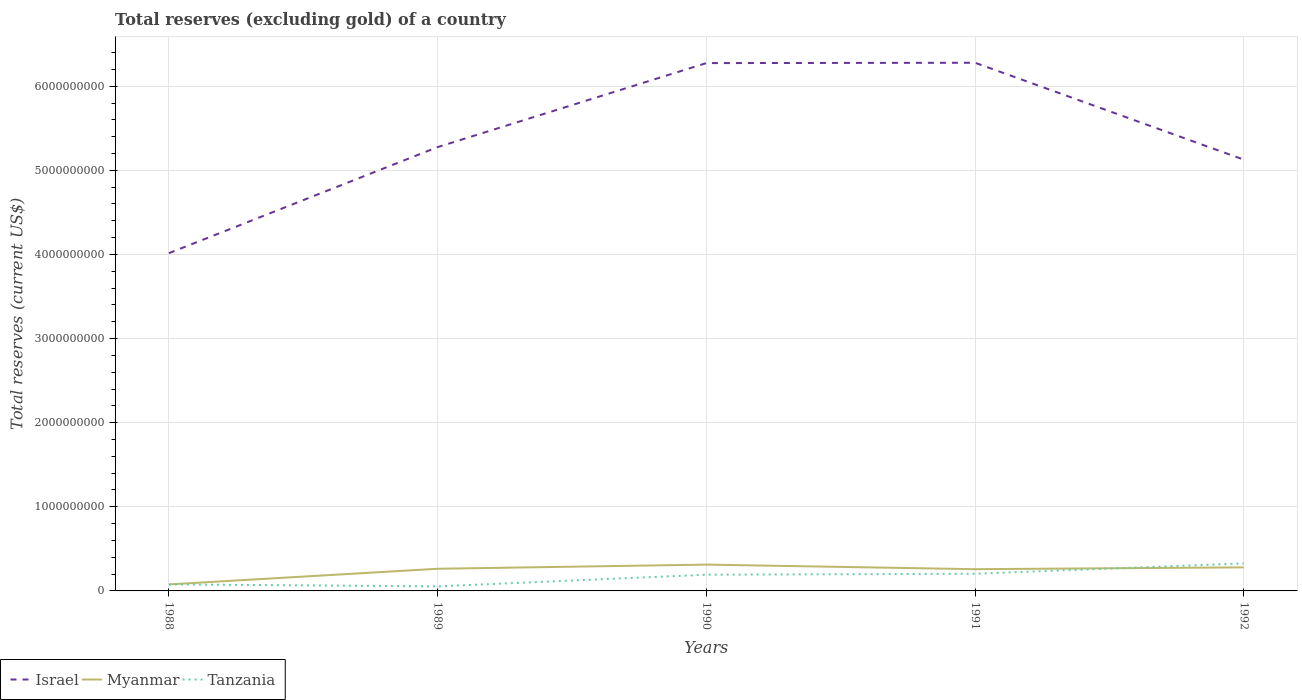Is the number of lines equal to the number of legend labels?
Your response must be concise. Yes. Across all years, what is the maximum total reserves (excluding gold) in Tanzania?
Provide a succinct answer. 5.42e+07. In which year was the total reserves (excluding gold) in Israel maximum?
Offer a terse response. 1988. What is the total total reserves (excluding gold) in Tanzania in the graph?
Make the answer very short. -1.26e+08. What is the difference between the highest and the second highest total reserves (excluding gold) in Israel?
Your response must be concise. 2.26e+09. How many lines are there?
Ensure brevity in your answer.  3. What is the difference between two consecutive major ticks on the Y-axis?
Your answer should be very brief. 1.00e+09. Does the graph contain any zero values?
Your response must be concise. No. Does the graph contain grids?
Make the answer very short. Yes. How are the legend labels stacked?
Give a very brief answer. Horizontal. What is the title of the graph?
Your response must be concise. Total reserves (excluding gold) of a country. Does "Norway" appear as one of the legend labels in the graph?
Your answer should be very brief. No. What is the label or title of the Y-axis?
Keep it short and to the point. Total reserves (current US$). What is the Total reserves (current US$) of Israel in 1988?
Your answer should be compact. 4.02e+09. What is the Total reserves (current US$) in Myanmar in 1988?
Offer a terse response. 7.74e+07. What is the Total reserves (current US$) in Tanzania in 1988?
Give a very brief answer. 7.77e+07. What is the Total reserves (current US$) in Israel in 1989?
Provide a short and direct response. 5.28e+09. What is the Total reserves (current US$) in Myanmar in 1989?
Make the answer very short. 2.63e+08. What is the Total reserves (current US$) of Tanzania in 1989?
Give a very brief answer. 5.42e+07. What is the Total reserves (current US$) of Israel in 1990?
Provide a short and direct response. 6.28e+09. What is the Total reserves (current US$) in Myanmar in 1990?
Ensure brevity in your answer.  3.13e+08. What is the Total reserves (current US$) of Tanzania in 1990?
Your answer should be very brief. 1.93e+08. What is the Total reserves (current US$) in Israel in 1991?
Provide a succinct answer. 6.28e+09. What is the Total reserves (current US$) of Myanmar in 1991?
Your answer should be very brief. 2.58e+08. What is the Total reserves (current US$) of Tanzania in 1991?
Keep it short and to the point. 2.04e+08. What is the Total reserves (current US$) of Israel in 1992?
Keep it short and to the point. 5.13e+09. What is the Total reserves (current US$) of Myanmar in 1992?
Your answer should be compact. 2.80e+08. What is the Total reserves (current US$) in Tanzania in 1992?
Your answer should be compact. 3.27e+08. Across all years, what is the maximum Total reserves (current US$) of Israel?
Offer a terse response. 6.28e+09. Across all years, what is the maximum Total reserves (current US$) of Myanmar?
Ensure brevity in your answer.  3.13e+08. Across all years, what is the maximum Total reserves (current US$) in Tanzania?
Ensure brevity in your answer.  3.27e+08. Across all years, what is the minimum Total reserves (current US$) of Israel?
Ensure brevity in your answer.  4.02e+09. Across all years, what is the minimum Total reserves (current US$) of Myanmar?
Your response must be concise. 7.74e+07. Across all years, what is the minimum Total reserves (current US$) of Tanzania?
Provide a succinct answer. 5.42e+07. What is the total Total reserves (current US$) of Israel in the graph?
Offer a very short reply. 2.70e+1. What is the total Total reserves (current US$) of Myanmar in the graph?
Provide a short and direct response. 1.19e+09. What is the total Total reserves (current US$) of Tanzania in the graph?
Provide a succinct answer. 8.56e+08. What is the difference between the Total reserves (current US$) in Israel in 1988 and that in 1989?
Your answer should be very brief. -1.26e+09. What is the difference between the Total reserves (current US$) in Myanmar in 1988 and that in 1989?
Provide a succinct answer. -1.86e+08. What is the difference between the Total reserves (current US$) of Tanzania in 1988 and that in 1989?
Provide a short and direct response. 2.35e+07. What is the difference between the Total reserves (current US$) in Israel in 1988 and that in 1990?
Your answer should be very brief. -2.26e+09. What is the difference between the Total reserves (current US$) of Myanmar in 1988 and that in 1990?
Your answer should be compact. -2.35e+08. What is the difference between the Total reserves (current US$) in Tanzania in 1988 and that in 1990?
Your answer should be compact. -1.15e+08. What is the difference between the Total reserves (current US$) of Israel in 1988 and that in 1991?
Provide a short and direct response. -2.26e+09. What is the difference between the Total reserves (current US$) of Myanmar in 1988 and that in 1991?
Your answer should be compact. -1.81e+08. What is the difference between the Total reserves (current US$) in Tanzania in 1988 and that in 1991?
Keep it short and to the point. -1.26e+08. What is the difference between the Total reserves (current US$) in Israel in 1988 and that in 1992?
Provide a succinct answer. -1.11e+09. What is the difference between the Total reserves (current US$) in Myanmar in 1988 and that in 1992?
Give a very brief answer. -2.03e+08. What is the difference between the Total reserves (current US$) of Tanzania in 1988 and that in 1992?
Your response must be concise. -2.50e+08. What is the difference between the Total reserves (current US$) of Israel in 1989 and that in 1990?
Keep it short and to the point. -9.99e+08. What is the difference between the Total reserves (current US$) of Myanmar in 1989 and that in 1990?
Ensure brevity in your answer.  -4.94e+07. What is the difference between the Total reserves (current US$) of Tanzania in 1989 and that in 1990?
Ensure brevity in your answer.  -1.39e+08. What is the difference between the Total reserves (current US$) of Israel in 1989 and that in 1991?
Make the answer very short. -1.00e+09. What is the difference between the Total reserves (current US$) of Myanmar in 1989 and that in 1991?
Offer a terse response. 4.99e+06. What is the difference between the Total reserves (current US$) of Tanzania in 1989 and that in 1991?
Make the answer very short. -1.50e+08. What is the difference between the Total reserves (current US$) in Israel in 1989 and that in 1992?
Provide a succinct answer. 1.49e+08. What is the difference between the Total reserves (current US$) in Myanmar in 1989 and that in 1992?
Give a very brief answer. -1.67e+07. What is the difference between the Total reserves (current US$) in Tanzania in 1989 and that in 1992?
Your answer should be very brief. -2.73e+08. What is the difference between the Total reserves (current US$) of Israel in 1990 and that in 1991?
Offer a very short reply. -3.96e+06. What is the difference between the Total reserves (current US$) of Myanmar in 1990 and that in 1991?
Provide a succinct answer. 5.44e+07. What is the difference between the Total reserves (current US$) of Tanzania in 1990 and that in 1991?
Offer a terse response. -1.11e+07. What is the difference between the Total reserves (current US$) of Israel in 1990 and that in 1992?
Provide a succinct answer. 1.15e+09. What is the difference between the Total reserves (current US$) in Myanmar in 1990 and that in 1992?
Ensure brevity in your answer.  3.27e+07. What is the difference between the Total reserves (current US$) of Tanzania in 1990 and that in 1992?
Give a very brief answer. -1.35e+08. What is the difference between the Total reserves (current US$) in Israel in 1991 and that in 1992?
Give a very brief answer. 1.15e+09. What is the difference between the Total reserves (current US$) of Myanmar in 1991 and that in 1992?
Ensure brevity in your answer.  -2.17e+07. What is the difference between the Total reserves (current US$) of Tanzania in 1991 and that in 1992?
Give a very brief answer. -1.23e+08. What is the difference between the Total reserves (current US$) of Israel in 1988 and the Total reserves (current US$) of Myanmar in 1989?
Your response must be concise. 3.75e+09. What is the difference between the Total reserves (current US$) of Israel in 1988 and the Total reserves (current US$) of Tanzania in 1989?
Ensure brevity in your answer.  3.96e+09. What is the difference between the Total reserves (current US$) in Myanmar in 1988 and the Total reserves (current US$) in Tanzania in 1989?
Offer a very short reply. 2.32e+07. What is the difference between the Total reserves (current US$) of Israel in 1988 and the Total reserves (current US$) of Myanmar in 1990?
Offer a terse response. 3.70e+09. What is the difference between the Total reserves (current US$) in Israel in 1988 and the Total reserves (current US$) in Tanzania in 1990?
Your response must be concise. 3.82e+09. What is the difference between the Total reserves (current US$) of Myanmar in 1988 and the Total reserves (current US$) of Tanzania in 1990?
Offer a very short reply. -1.15e+08. What is the difference between the Total reserves (current US$) in Israel in 1988 and the Total reserves (current US$) in Myanmar in 1991?
Provide a short and direct response. 3.76e+09. What is the difference between the Total reserves (current US$) in Israel in 1988 and the Total reserves (current US$) in Tanzania in 1991?
Make the answer very short. 3.81e+09. What is the difference between the Total reserves (current US$) of Myanmar in 1988 and the Total reserves (current US$) of Tanzania in 1991?
Your response must be concise. -1.26e+08. What is the difference between the Total reserves (current US$) of Israel in 1988 and the Total reserves (current US$) of Myanmar in 1992?
Provide a succinct answer. 3.74e+09. What is the difference between the Total reserves (current US$) in Israel in 1988 and the Total reserves (current US$) in Tanzania in 1992?
Your answer should be compact. 3.69e+09. What is the difference between the Total reserves (current US$) of Myanmar in 1988 and the Total reserves (current US$) of Tanzania in 1992?
Your response must be concise. -2.50e+08. What is the difference between the Total reserves (current US$) of Israel in 1989 and the Total reserves (current US$) of Myanmar in 1990?
Offer a very short reply. 4.96e+09. What is the difference between the Total reserves (current US$) of Israel in 1989 and the Total reserves (current US$) of Tanzania in 1990?
Keep it short and to the point. 5.08e+09. What is the difference between the Total reserves (current US$) in Myanmar in 1989 and the Total reserves (current US$) in Tanzania in 1990?
Ensure brevity in your answer.  7.06e+07. What is the difference between the Total reserves (current US$) of Israel in 1989 and the Total reserves (current US$) of Myanmar in 1991?
Keep it short and to the point. 5.02e+09. What is the difference between the Total reserves (current US$) in Israel in 1989 and the Total reserves (current US$) in Tanzania in 1991?
Give a very brief answer. 5.07e+09. What is the difference between the Total reserves (current US$) in Myanmar in 1989 and the Total reserves (current US$) in Tanzania in 1991?
Your answer should be compact. 5.95e+07. What is the difference between the Total reserves (current US$) of Israel in 1989 and the Total reserves (current US$) of Myanmar in 1992?
Keep it short and to the point. 5.00e+09. What is the difference between the Total reserves (current US$) in Israel in 1989 and the Total reserves (current US$) in Tanzania in 1992?
Your answer should be compact. 4.95e+09. What is the difference between the Total reserves (current US$) in Myanmar in 1989 and the Total reserves (current US$) in Tanzania in 1992?
Give a very brief answer. -6.40e+07. What is the difference between the Total reserves (current US$) of Israel in 1990 and the Total reserves (current US$) of Myanmar in 1991?
Make the answer very short. 6.02e+09. What is the difference between the Total reserves (current US$) of Israel in 1990 and the Total reserves (current US$) of Tanzania in 1991?
Keep it short and to the point. 6.07e+09. What is the difference between the Total reserves (current US$) of Myanmar in 1990 and the Total reserves (current US$) of Tanzania in 1991?
Provide a succinct answer. 1.09e+08. What is the difference between the Total reserves (current US$) of Israel in 1990 and the Total reserves (current US$) of Myanmar in 1992?
Offer a very short reply. 6.00e+09. What is the difference between the Total reserves (current US$) of Israel in 1990 and the Total reserves (current US$) of Tanzania in 1992?
Provide a succinct answer. 5.95e+09. What is the difference between the Total reserves (current US$) of Myanmar in 1990 and the Total reserves (current US$) of Tanzania in 1992?
Give a very brief answer. -1.45e+07. What is the difference between the Total reserves (current US$) in Israel in 1991 and the Total reserves (current US$) in Myanmar in 1992?
Give a very brief answer. 6.00e+09. What is the difference between the Total reserves (current US$) in Israel in 1991 and the Total reserves (current US$) in Tanzania in 1992?
Your response must be concise. 5.95e+09. What is the difference between the Total reserves (current US$) of Myanmar in 1991 and the Total reserves (current US$) of Tanzania in 1992?
Provide a short and direct response. -6.90e+07. What is the average Total reserves (current US$) of Israel per year?
Your response must be concise. 5.39e+09. What is the average Total reserves (current US$) of Myanmar per year?
Offer a very short reply. 2.38e+08. What is the average Total reserves (current US$) in Tanzania per year?
Offer a terse response. 1.71e+08. In the year 1988, what is the difference between the Total reserves (current US$) in Israel and Total reserves (current US$) in Myanmar?
Your answer should be very brief. 3.94e+09. In the year 1988, what is the difference between the Total reserves (current US$) of Israel and Total reserves (current US$) of Tanzania?
Your response must be concise. 3.94e+09. In the year 1988, what is the difference between the Total reserves (current US$) in Myanmar and Total reserves (current US$) in Tanzania?
Keep it short and to the point. -2.79e+05. In the year 1989, what is the difference between the Total reserves (current US$) of Israel and Total reserves (current US$) of Myanmar?
Offer a terse response. 5.01e+09. In the year 1989, what is the difference between the Total reserves (current US$) of Israel and Total reserves (current US$) of Tanzania?
Provide a short and direct response. 5.22e+09. In the year 1989, what is the difference between the Total reserves (current US$) in Myanmar and Total reserves (current US$) in Tanzania?
Provide a succinct answer. 2.09e+08. In the year 1990, what is the difference between the Total reserves (current US$) of Israel and Total reserves (current US$) of Myanmar?
Your answer should be very brief. 5.96e+09. In the year 1990, what is the difference between the Total reserves (current US$) of Israel and Total reserves (current US$) of Tanzania?
Provide a succinct answer. 6.08e+09. In the year 1990, what is the difference between the Total reserves (current US$) in Myanmar and Total reserves (current US$) in Tanzania?
Provide a short and direct response. 1.20e+08. In the year 1991, what is the difference between the Total reserves (current US$) of Israel and Total reserves (current US$) of Myanmar?
Provide a succinct answer. 6.02e+09. In the year 1991, what is the difference between the Total reserves (current US$) of Israel and Total reserves (current US$) of Tanzania?
Keep it short and to the point. 6.08e+09. In the year 1991, what is the difference between the Total reserves (current US$) of Myanmar and Total reserves (current US$) of Tanzania?
Give a very brief answer. 5.45e+07. In the year 1992, what is the difference between the Total reserves (current US$) in Israel and Total reserves (current US$) in Myanmar?
Give a very brief answer. 4.85e+09. In the year 1992, what is the difference between the Total reserves (current US$) in Israel and Total reserves (current US$) in Tanzania?
Give a very brief answer. 4.80e+09. In the year 1992, what is the difference between the Total reserves (current US$) of Myanmar and Total reserves (current US$) of Tanzania?
Offer a very short reply. -4.72e+07. What is the ratio of the Total reserves (current US$) in Israel in 1988 to that in 1989?
Ensure brevity in your answer.  0.76. What is the ratio of the Total reserves (current US$) in Myanmar in 1988 to that in 1989?
Offer a terse response. 0.29. What is the ratio of the Total reserves (current US$) of Tanzania in 1988 to that in 1989?
Provide a short and direct response. 1.43. What is the ratio of the Total reserves (current US$) in Israel in 1988 to that in 1990?
Offer a terse response. 0.64. What is the ratio of the Total reserves (current US$) of Myanmar in 1988 to that in 1990?
Keep it short and to the point. 0.25. What is the ratio of the Total reserves (current US$) of Tanzania in 1988 to that in 1990?
Give a very brief answer. 0.4. What is the ratio of the Total reserves (current US$) of Israel in 1988 to that in 1991?
Your answer should be very brief. 0.64. What is the ratio of the Total reserves (current US$) of Myanmar in 1988 to that in 1991?
Offer a very short reply. 0.3. What is the ratio of the Total reserves (current US$) of Tanzania in 1988 to that in 1991?
Give a very brief answer. 0.38. What is the ratio of the Total reserves (current US$) of Israel in 1988 to that in 1992?
Keep it short and to the point. 0.78. What is the ratio of the Total reserves (current US$) of Myanmar in 1988 to that in 1992?
Make the answer very short. 0.28. What is the ratio of the Total reserves (current US$) of Tanzania in 1988 to that in 1992?
Provide a succinct answer. 0.24. What is the ratio of the Total reserves (current US$) of Israel in 1989 to that in 1990?
Your answer should be very brief. 0.84. What is the ratio of the Total reserves (current US$) of Myanmar in 1989 to that in 1990?
Provide a short and direct response. 0.84. What is the ratio of the Total reserves (current US$) in Tanzania in 1989 to that in 1990?
Provide a short and direct response. 0.28. What is the ratio of the Total reserves (current US$) in Israel in 1989 to that in 1991?
Provide a succinct answer. 0.84. What is the ratio of the Total reserves (current US$) of Myanmar in 1989 to that in 1991?
Your answer should be very brief. 1.02. What is the ratio of the Total reserves (current US$) of Tanzania in 1989 to that in 1991?
Keep it short and to the point. 0.27. What is the ratio of the Total reserves (current US$) in Israel in 1989 to that in 1992?
Provide a succinct answer. 1.03. What is the ratio of the Total reserves (current US$) of Myanmar in 1989 to that in 1992?
Your answer should be very brief. 0.94. What is the ratio of the Total reserves (current US$) in Tanzania in 1989 to that in 1992?
Ensure brevity in your answer.  0.17. What is the ratio of the Total reserves (current US$) of Myanmar in 1990 to that in 1991?
Your answer should be very brief. 1.21. What is the ratio of the Total reserves (current US$) of Tanzania in 1990 to that in 1991?
Make the answer very short. 0.95. What is the ratio of the Total reserves (current US$) of Israel in 1990 to that in 1992?
Your answer should be compact. 1.22. What is the ratio of the Total reserves (current US$) of Myanmar in 1990 to that in 1992?
Provide a succinct answer. 1.12. What is the ratio of the Total reserves (current US$) in Tanzania in 1990 to that in 1992?
Offer a very short reply. 0.59. What is the ratio of the Total reserves (current US$) in Israel in 1991 to that in 1992?
Your response must be concise. 1.22. What is the ratio of the Total reserves (current US$) of Myanmar in 1991 to that in 1992?
Keep it short and to the point. 0.92. What is the ratio of the Total reserves (current US$) of Tanzania in 1991 to that in 1992?
Your answer should be compact. 0.62. What is the difference between the highest and the second highest Total reserves (current US$) of Israel?
Ensure brevity in your answer.  3.96e+06. What is the difference between the highest and the second highest Total reserves (current US$) of Myanmar?
Ensure brevity in your answer.  3.27e+07. What is the difference between the highest and the second highest Total reserves (current US$) in Tanzania?
Offer a terse response. 1.23e+08. What is the difference between the highest and the lowest Total reserves (current US$) of Israel?
Offer a terse response. 2.26e+09. What is the difference between the highest and the lowest Total reserves (current US$) in Myanmar?
Give a very brief answer. 2.35e+08. What is the difference between the highest and the lowest Total reserves (current US$) in Tanzania?
Your answer should be compact. 2.73e+08. 